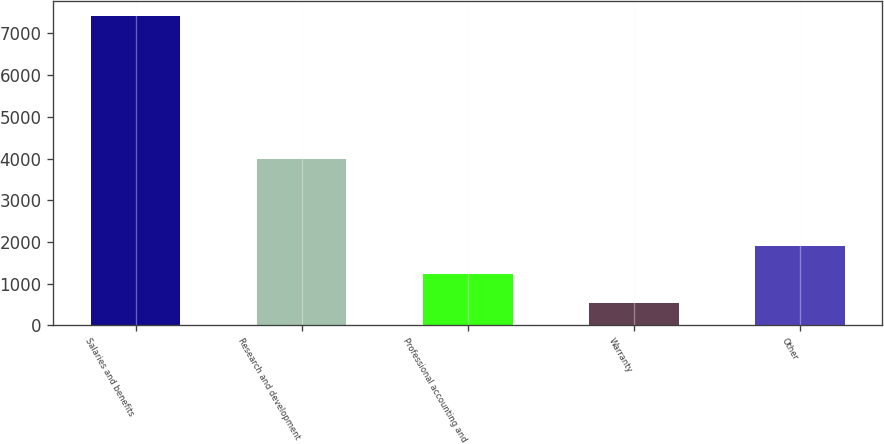Convert chart. <chart><loc_0><loc_0><loc_500><loc_500><bar_chart><fcel>Salaries and benefits<fcel>Research and development<fcel>Professional accounting and<fcel>Warranty<fcel>Other<nl><fcel>7416<fcel>3991<fcel>1224.9<fcel>537<fcel>1912.8<nl></chart> 